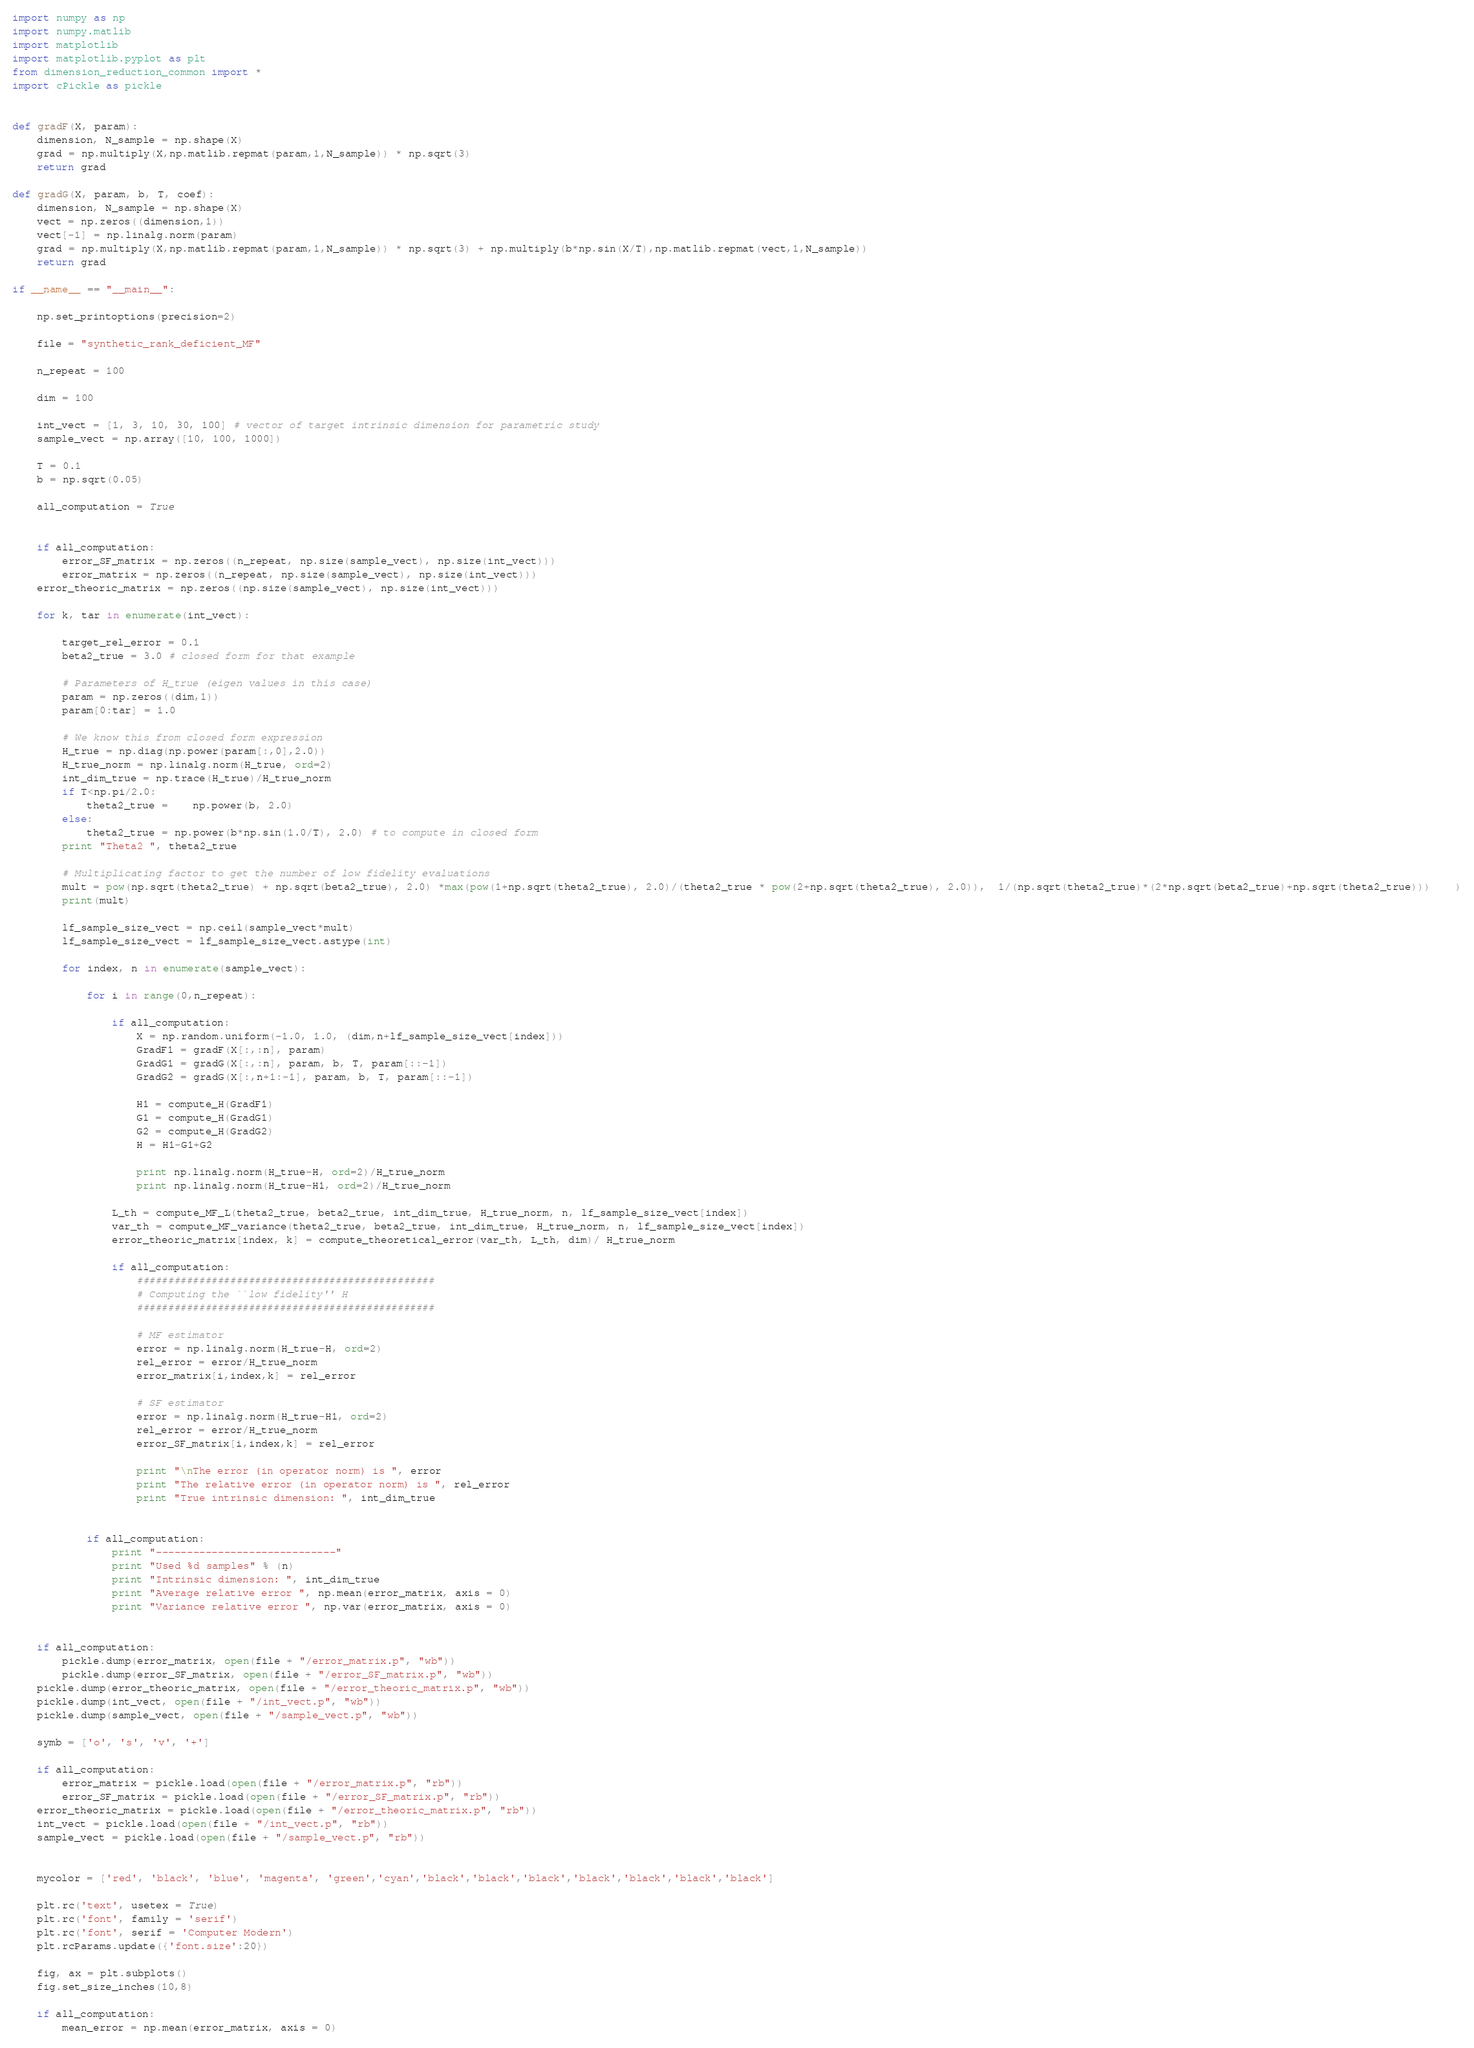<code> <loc_0><loc_0><loc_500><loc_500><_Python_>import numpy as np
import numpy.matlib
import matplotlib
import matplotlib.pyplot as plt
from dimension_reduction_common import *
import cPickle as pickle


def gradF(X, param):
	dimension, N_sample = np.shape(X)
	grad = np.multiply(X,np.matlib.repmat(param,1,N_sample)) * np.sqrt(3)
	return grad

def gradG(X, param, b, T, coef):
	dimension, N_sample = np.shape(X)
	vect = np.zeros((dimension,1))
	vect[-1] = np.linalg.norm(param)
	grad = np.multiply(X,np.matlib.repmat(param,1,N_sample)) * np.sqrt(3) + np.multiply(b*np.sin(X/T),np.matlib.repmat(vect,1,N_sample))
	return grad

if __name__ == "__main__":

	np.set_printoptions(precision=2)

	file = "synthetic_rank_deficient_MF"

	n_repeat = 100

	dim = 100

	int_vect = [1, 3, 10, 30, 100] # vector of target intrinsic dimension for parametric study
	sample_vect = np.array([10, 100, 1000])

	T = 0.1
	b = np.sqrt(0.05)

	all_computation = True


	if all_computation:
		error_SF_matrix = np.zeros((n_repeat, np.size(sample_vect), np.size(int_vect)))
		error_matrix = np.zeros((n_repeat, np.size(sample_vect), np.size(int_vect)))
	error_theoric_matrix = np.zeros((np.size(sample_vect), np.size(int_vect)))

	for k, tar in enumerate(int_vect):

		target_rel_error = 0.1
		beta2_true = 3.0 # closed form for that example
		
		# Parameters of H_true (eigen values in this case)
		param = np.zeros((dim,1))
		param[0:tar] = 1.0

		# We know this from closed form expression
		H_true = np.diag(np.power(param[:,0],2.0))
		H_true_norm = np.linalg.norm(H_true, ord=2)
		int_dim_true = np.trace(H_true)/H_true_norm
		if T<np.pi/2.0:
			theta2_true = 	np.power(b, 2.0)
		else:
			theta2_true = np.power(b*np.sin(1.0/T), 2.0) # to compute in closed form
		print "Theta2 ", theta2_true
		
		# Multiplicating factor to get the number of low fidelity evaluations
		mult = pow(np.sqrt(theta2_true) + np.sqrt(beta2_true), 2.0) *max(pow(1+np.sqrt(theta2_true), 2.0)/(theta2_true * pow(2+np.sqrt(theta2_true), 2.0)),  1/(np.sqrt(theta2_true)*(2*np.sqrt(beta2_true)+np.sqrt(theta2_true)))    )
		print(mult)
		
		lf_sample_size_vect = np.ceil(sample_vect*mult)
		lf_sample_size_vect = lf_sample_size_vect.astype(int)
		
		for index, n in enumerate(sample_vect):

			for i in range(0,n_repeat):

				if all_computation:
					X = np.random.uniform(-1.0, 1.0, (dim,n+lf_sample_size_vect[index]))
					GradF1 = gradF(X[:,:n], param)
					GradG1 = gradG(X[:,:n], param, b, T, param[::-1])
					GradG2 = gradG(X[:,n+1:-1], param, b, T, param[::-1])

					H1 = compute_H(GradF1)
					G1 = compute_H(GradG1)
					G2 = compute_H(GradG2)
					H = H1-G1+G2

					print np.linalg.norm(H_true-H, ord=2)/H_true_norm
					print np.linalg.norm(H_true-H1, ord=2)/H_true_norm

				L_th = compute_MF_L(theta2_true, beta2_true, int_dim_true, H_true_norm, n, lf_sample_size_vect[index])
				var_th = compute_MF_variance(theta2_true, beta2_true, int_dim_true, H_true_norm, n, lf_sample_size_vect[index])
				error_theoric_matrix[index, k] = compute_theoretical_error(var_th, L_th, dim)/ H_true_norm

				if all_computation:
					################################################
					# Computing the ``low fidelity'' H
					################################################
					
					# MF estimator
					error = np.linalg.norm(H_true-H, ord=2)
					rel_error = error/H_true_norm
					error_matrix[i,index,k] = rel_error

					# SF estimator
					error = np.linalg.norm(H_true-H1, ord=2)
					rel_error = error/H_true_norm
					error_SF_matrix[i,index,k] = rel_error

					print "\nThe error (in operator norm) is ", error
					print "The relative error (in operator norm) is ", rel_error
					print "True intrinsic dimension: ", int_dim_true


			if all_computation:
				print "-----------------------------"
				print "Used %d samples" % (n)
				print "Intrinsic dimension: ", int_dim_true
				print "Average relative error ", np.mean(error_matrix, axis = 0)
				print "Variance relative error ", np.var(error_matrix, axis = 0)


	if all_computation:
		pickle.dump(error_matrix, open(file + "/error_matrix.p", "wb"))
		pickle.dump(error_SF_matrix, open(file + "/error_SF_matrix.p", "wb"))
	pickle.dump(error_theoric_matrix, open(file + "/error_theoric_matrix.p", "wb"))
	pickle.dump(int_vect, open(file + "/int_vect.p", "wb"))
	pickle.dump(sample_vect, open(file + "/sample_vect.p", "wb"))

	symb = ['o', 's', 'v', '+']

	if all_computation:
		error_matrix = pickle.load(open(file + "/error_matrix.p", "rb"))
		error_SF_matrix = pickle.load(open(file + "/error_SF_matrix.p", "rb"))
	error_theoric_matrix = pickle.load(open(file + "/error_theoric_matrix.p", "rb"))
	int_vect = pickle.load(open(file + "/int_vect.p", "rb"))
	sample_vect = pickle.load(open(file + "/sample_vect.p", "rb"))


	mycolor = ['red', 'black', 'blue', 'magenta', 'green','cyan','black','black','black','black','black','black','black']

	plt.rc('text', usetex = True)
	plt.rc('font', family = 'serif')
	plt.rc('font', serif = 'Computer Modern')
	plt.rcParams.update({'font.size':20})

	fig, ax = plt.subplots()
	fig.set_size_inches(10,8)

	if all_computation:
		mean_error = np.mean(error_matrix, axis = 0)</code> 